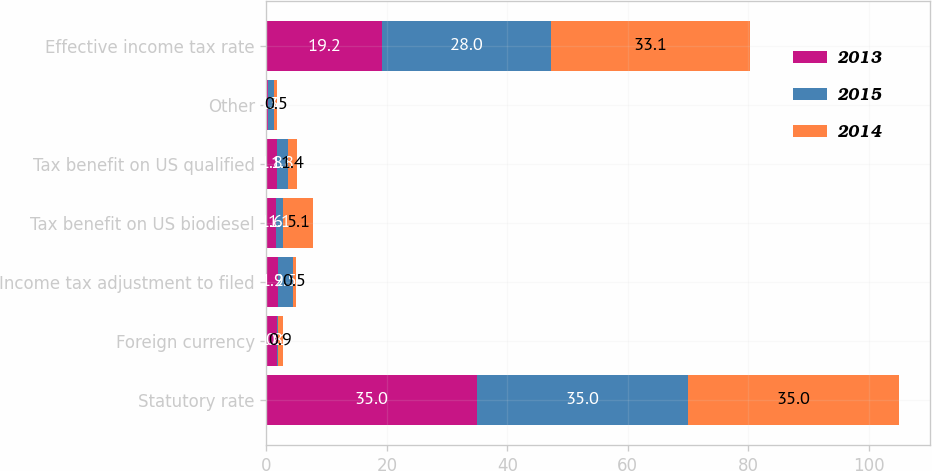Convert chart to OTSL. <chart><loc_0><loc_0><loc_500><loc_500><stacked_bar_chart><ecel><fcel>Statutory rate<fcel>Foreign currency<fcel>Income tax adjustment to filed<fcel>Tax benefit on US biodiesel<fcel>Tax benefit on US qualified<fcel>Other<fcel>Effective income tax rate<nl><fcel>2013<fcel>35<fcel>1.8<fcel>1.9<fcel>1.6<fcel>1.8<fcel>0.3<fcel>19.2<nl><fcel>2015<fcel>35<fcel>0.1<fcel>2.5<fcel>1.1<fcel>1.8<fcel>1<fcel>28<nl><fcel>2014<fcel>35<fcel>0.9<fcel>0.5<fcel>5.1<fcel>1.4<fcel>0.5<fcel>33.1<nl></chart> 